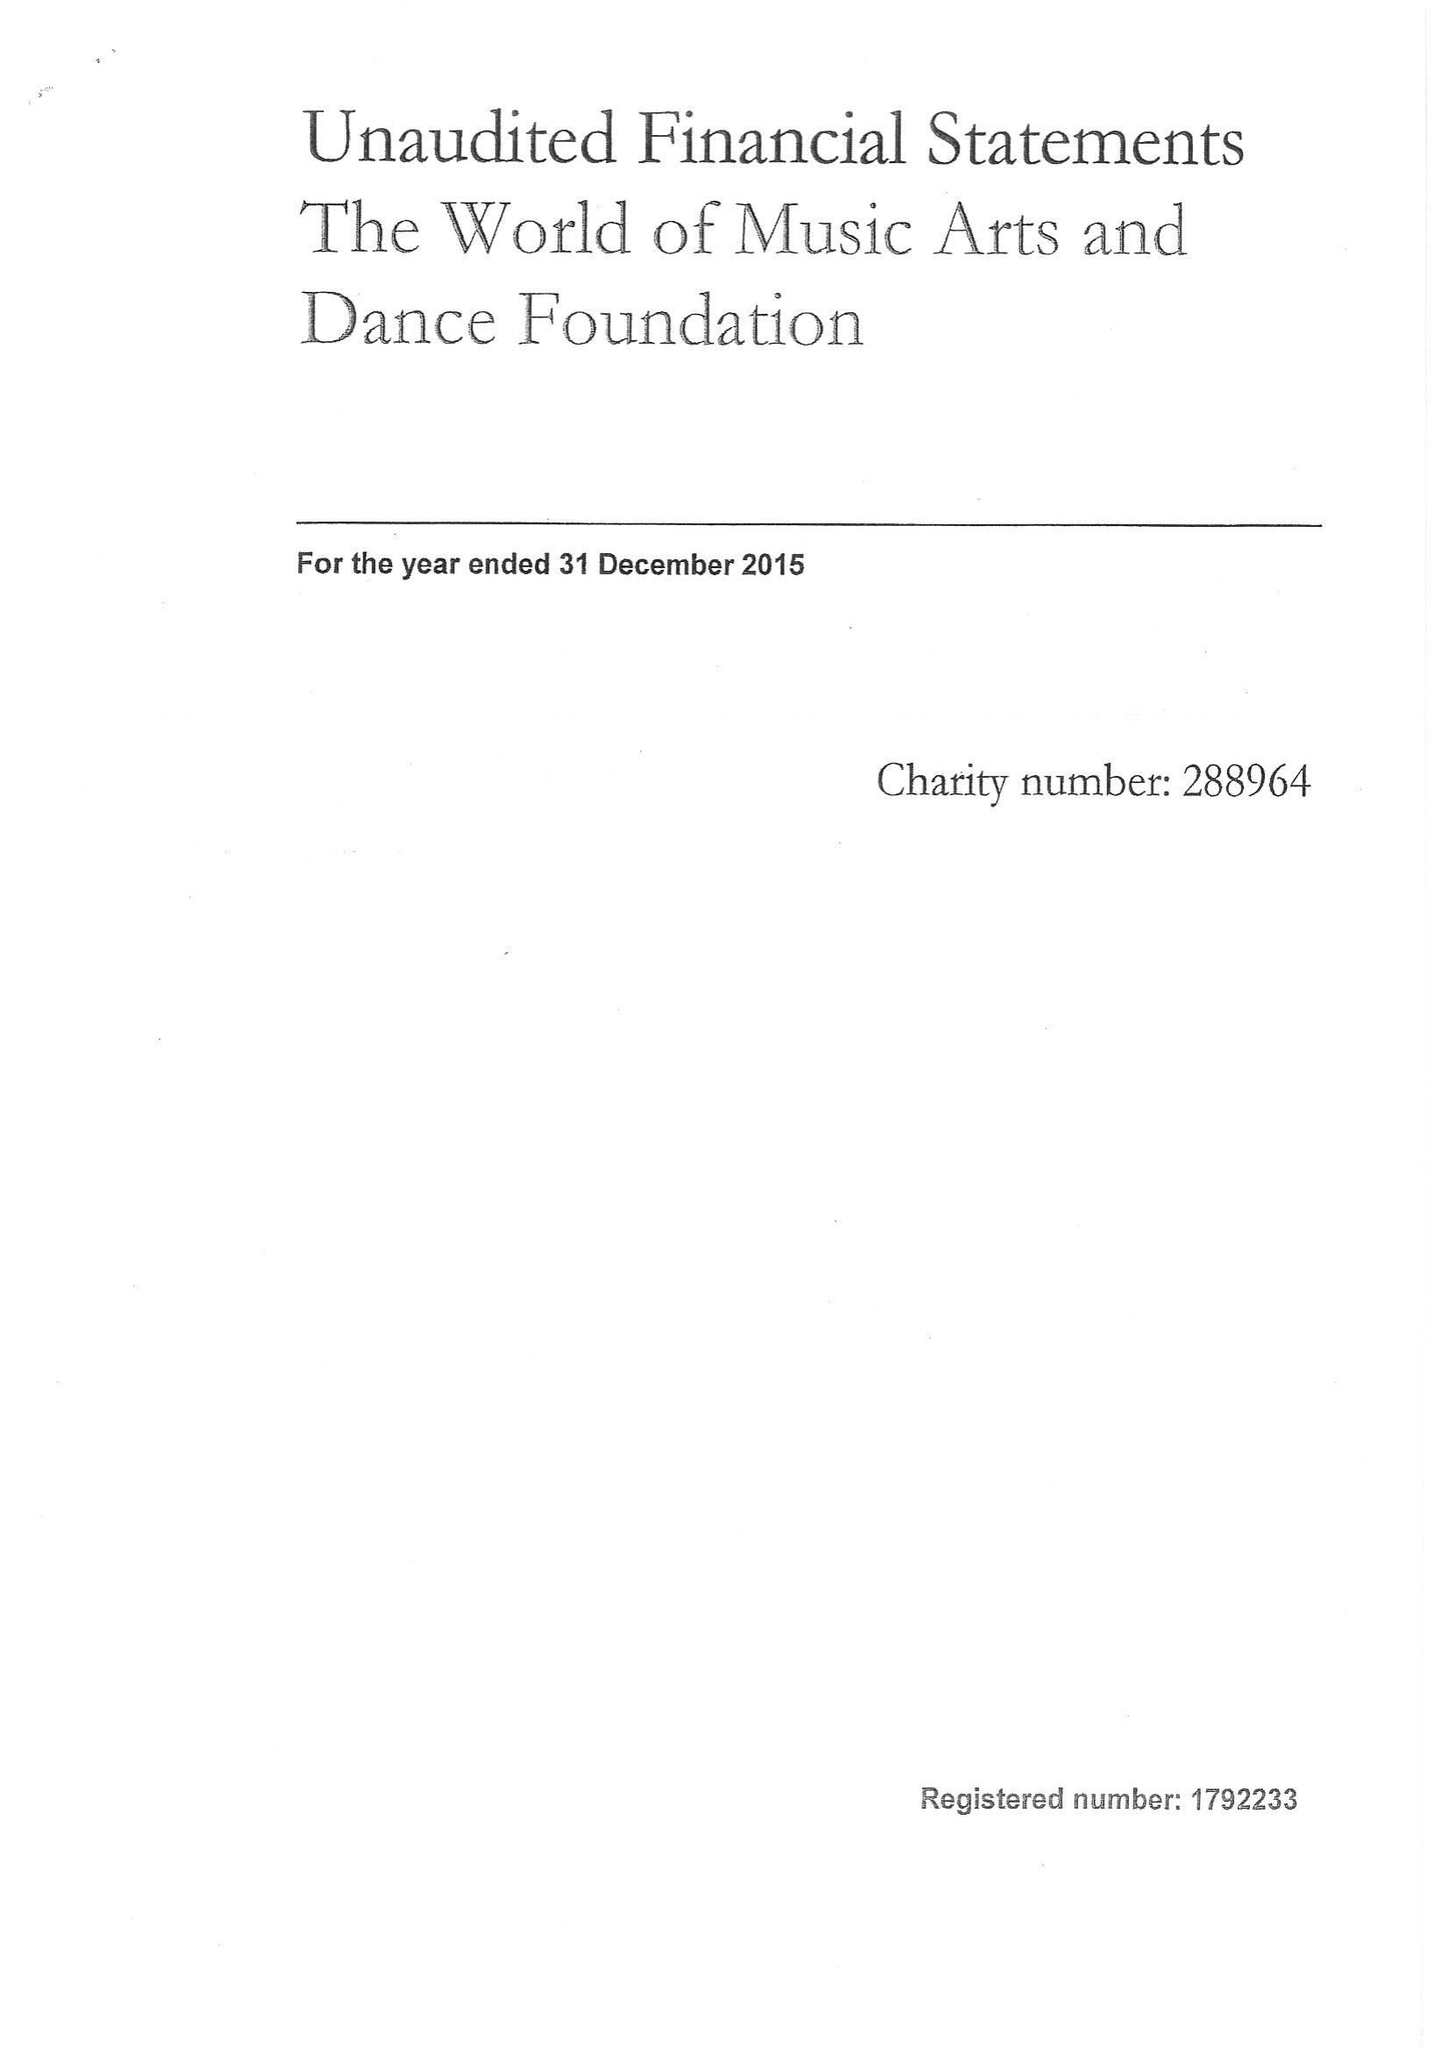What is the value for the charity_name?
Answer the question using a single word or phrase. The World Of Music Arts and Dance Foundation 